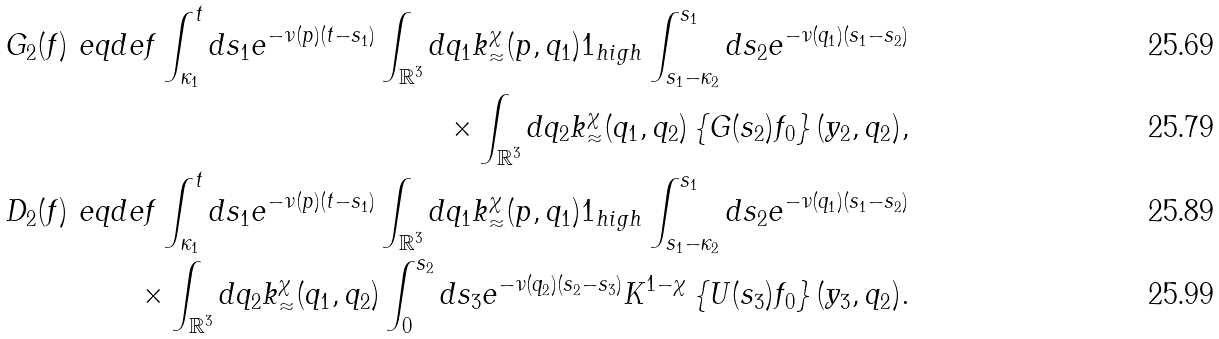<formula> <loc_0><loc_0><loc_500><loc_500>G _ { 2 } ( f ) \ e q d e f \int _ { \kappa _ { 1 } } ^ { t } d s _ { 1 } e ^ { - \nu ( p ) ( t - s _ { 1 } ) } \int _ { \mathbb { R } ^ { 3 } } d q _ { 1 } k _ { \approx } ^ { \chi } ( p , q _ { 1 } ) { 1 } _ { h i g h } \int _ { s _ { 1 } - \kappa _ { 2 } } ^ { s _ { 1 } } d s _ { 2 } e ^ { - \nu ( q _ { 1 } ) ( s _ { 1 } - s _ { 2 } ) } \\ \times \int _ { \mathbb { R } ^ { 3 } } d q _ { 2 } k _ { \approx } ^ { \chi } ( q _ { 1 } , q _ { 2 } ) \left \{ G ( s _ { 2 } ) f _ { 0 } \right \} ( y _ { 2 } , q _ { 2 } ) , \\ D _ { 2 } ( f ) \ e q d e f \int _ { \kappa _ { 1 } } ^ { t } d s _ { 1 } e ^ { - \nu ( p ) ( t - s _ { 1 } ) } \int _ { \mathbb { R } ^ { 3 } } d q _ { 1 } k _ { \approx } ^ { \chi } ( p , q _ { 1 } ) { 1 } _ { h i g h } \int _ { s _ { 1 } - \kappa _ { 2 } } ^ { s _ { 1 } } d s _ { 2 } e ^ { - \nu ( q _ { 1 } ) ( s _ { 1 } - s _ { 2 } ) } \\ \times \int _ { \mathbb { R } ^ { 3 } } d q _ { 2 } k _ { \approx } ^ { \chi } ( q _ { 1 } , q _ { 2 } ) \int _ { 0 } ^ { s _ { 2 } } d s _ { 3 } e ^ { - \nu ( q _ { 2 } ) ( s _ { 2 } - s _ { 3 } ) } K ^ { 1 - \chi } \left \{ U ( s _ { 3 } ) f _ { 0 } \right \} ( y _ { 3 } , q _ { 2 } ) .</formula> 